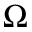Convert formula to latex. <formula><loc_0><loc_0><loc_500><loc_500>\Omega</formula> 